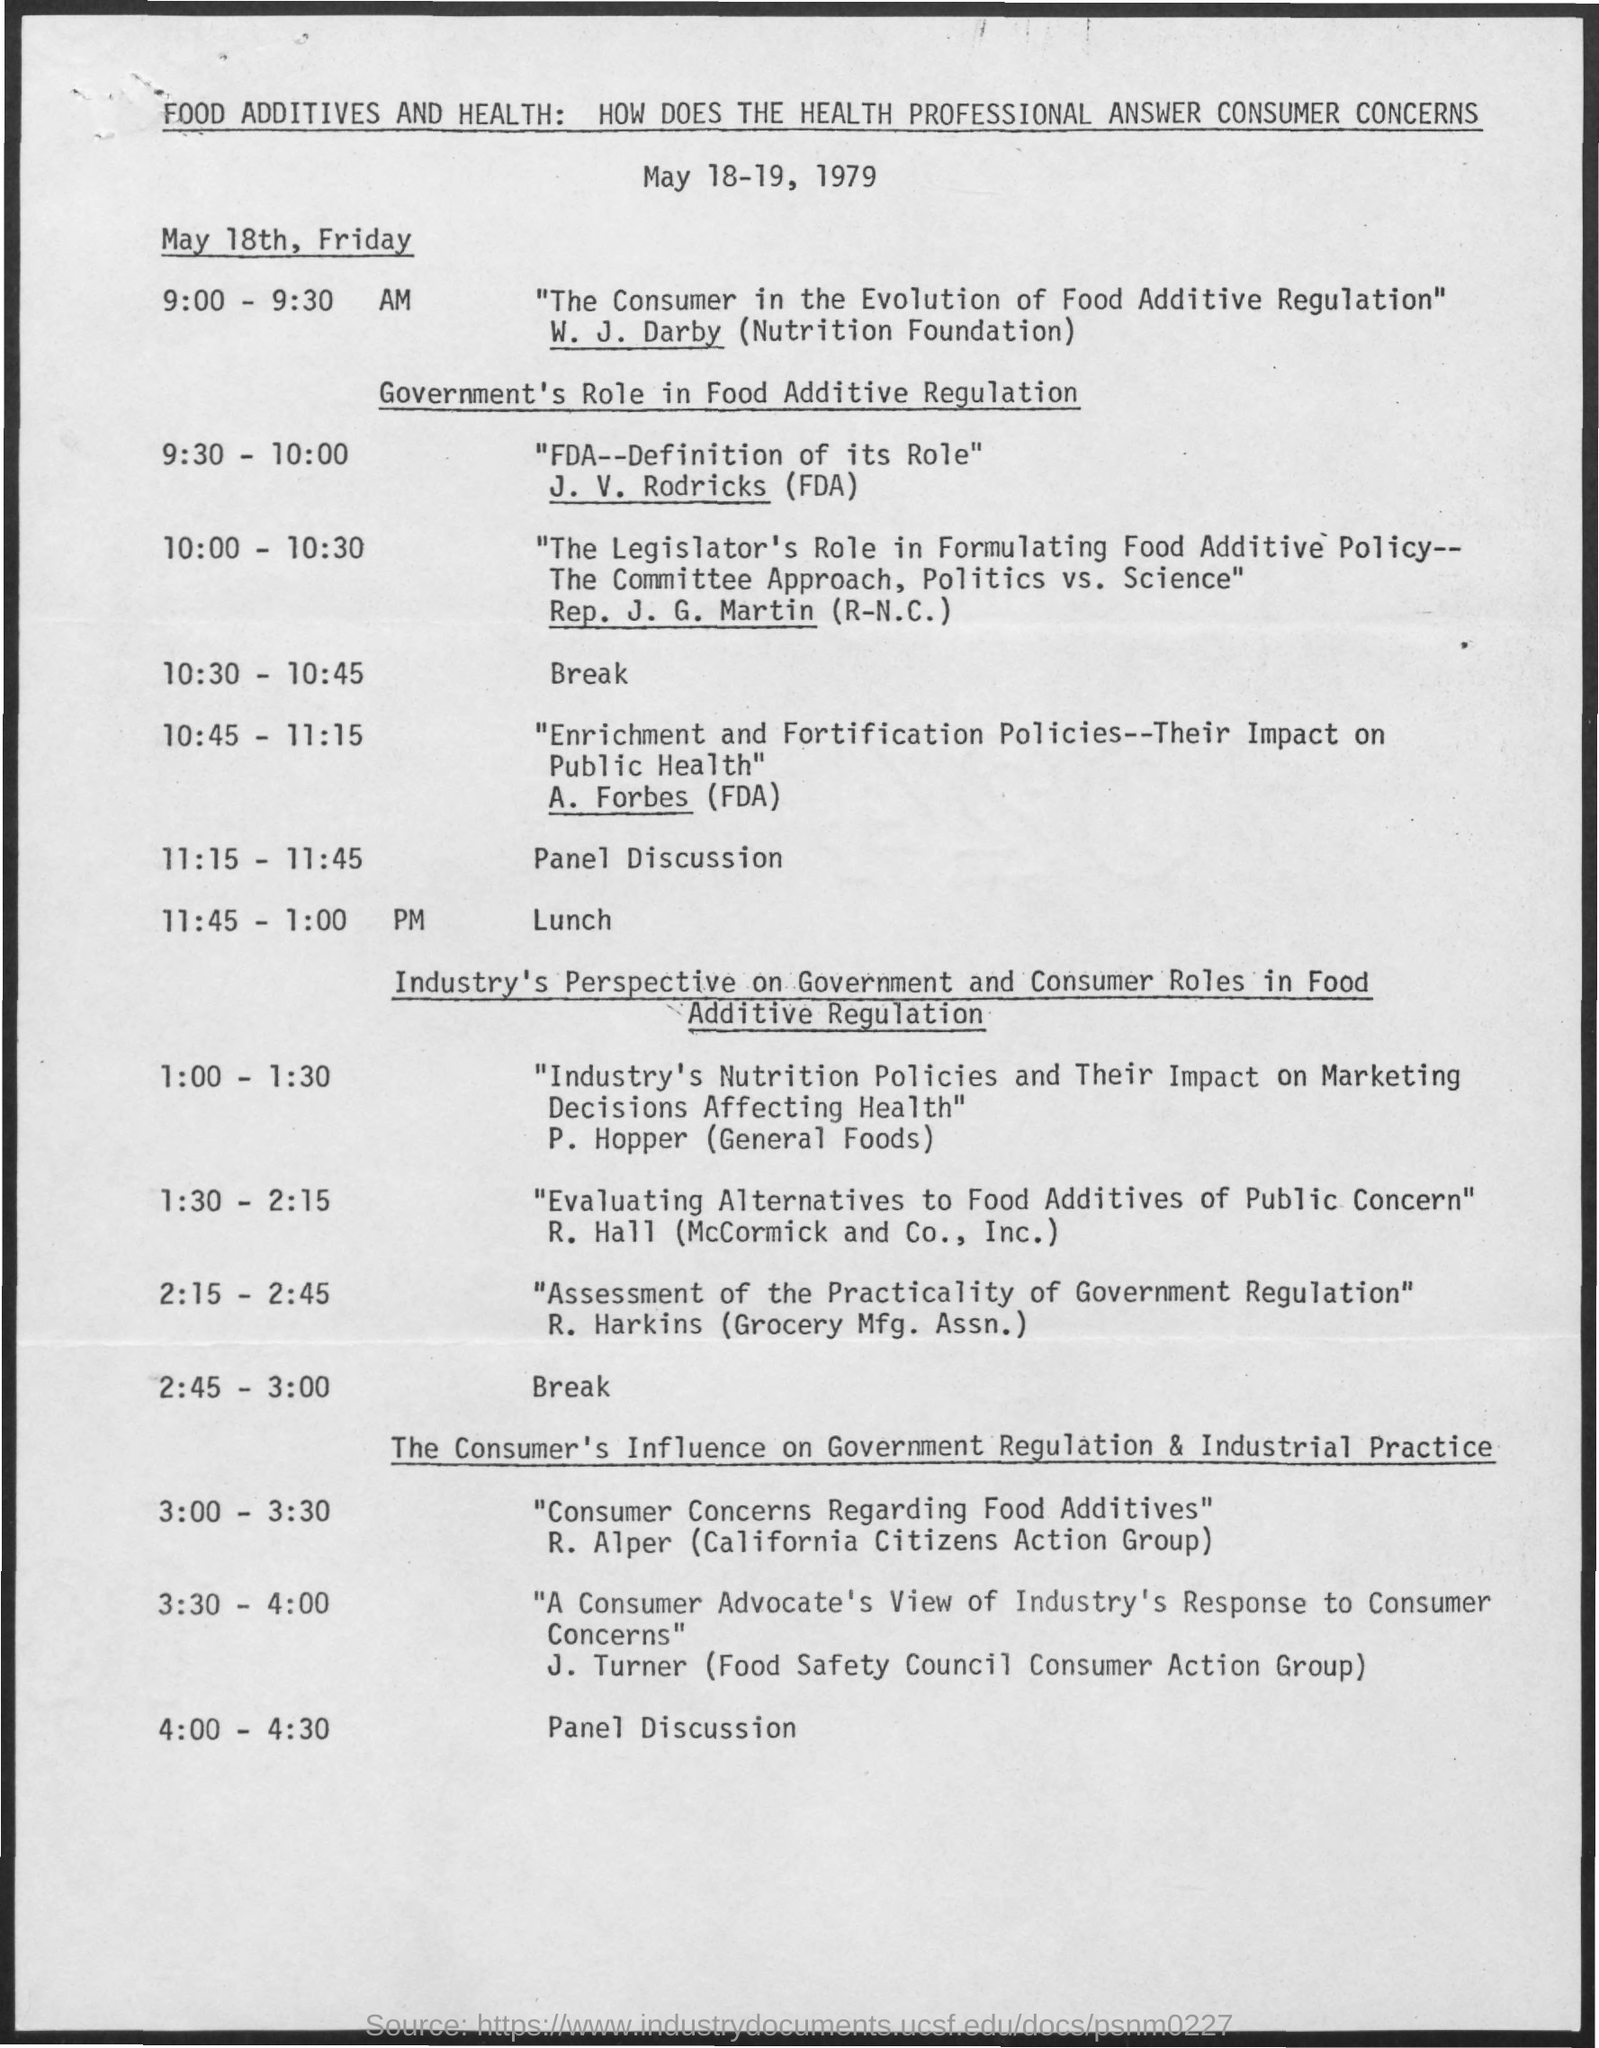What is the schedule at the time of 10:30 - 10:45 ?
Your response must be concise. Break. What is the schedule at the time of 11:15 - 11:45 ?
Provide a short and direct response. Panel discussion. What is the schedule at the time of 11:45 - 1:00 pm ?
Offer a terse response. LUNCH. What is the schedule at the time of 2:45 - 3:00 ?
Offer a very short reply. Break. What is the schedule at the time of 4:00 - 4:30 ?
Provide a succinct answer. Panel discussion. 